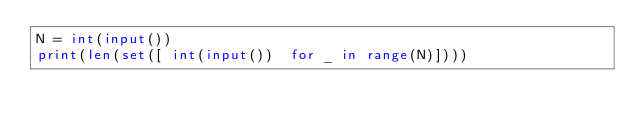Convert code to text. <code><loc_0><loc_0><loc_500><loc_500><_Python_>N = int(input())
print(len(set([ int(input())  for _ in range(N)])))</code> 